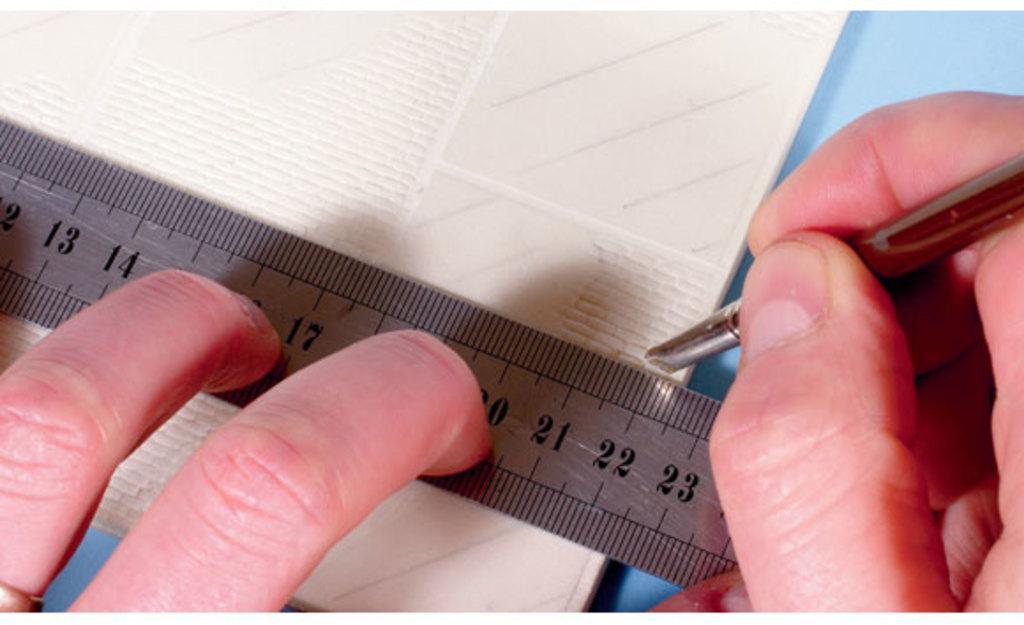Can you describe this image briefly? In this image, we can see human hand fingers holding some object. Here there is a measuring scale on the white object. Here we can see blue color. 